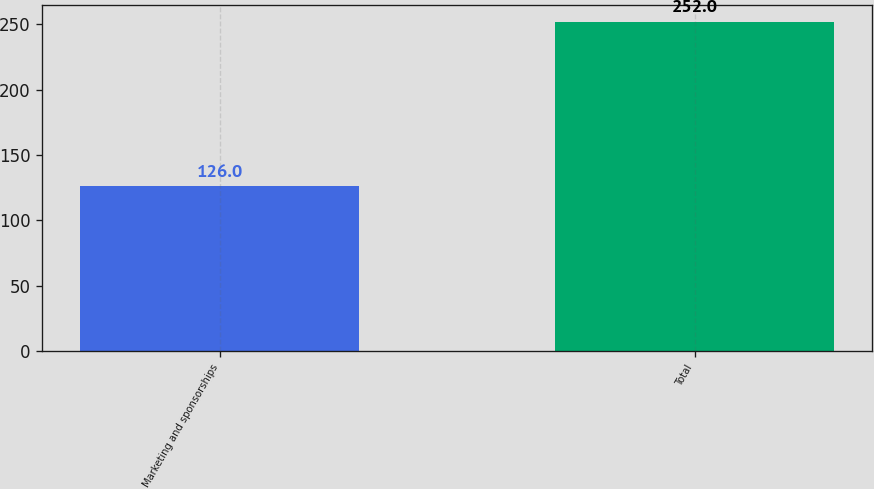<chart> <loc_0><loc_0><loc_500><loc_500><bar_chart><fcel>Marketing and sponsorships<fcel>Total<nl><fcel>126<fcel>252<nl></chart> 